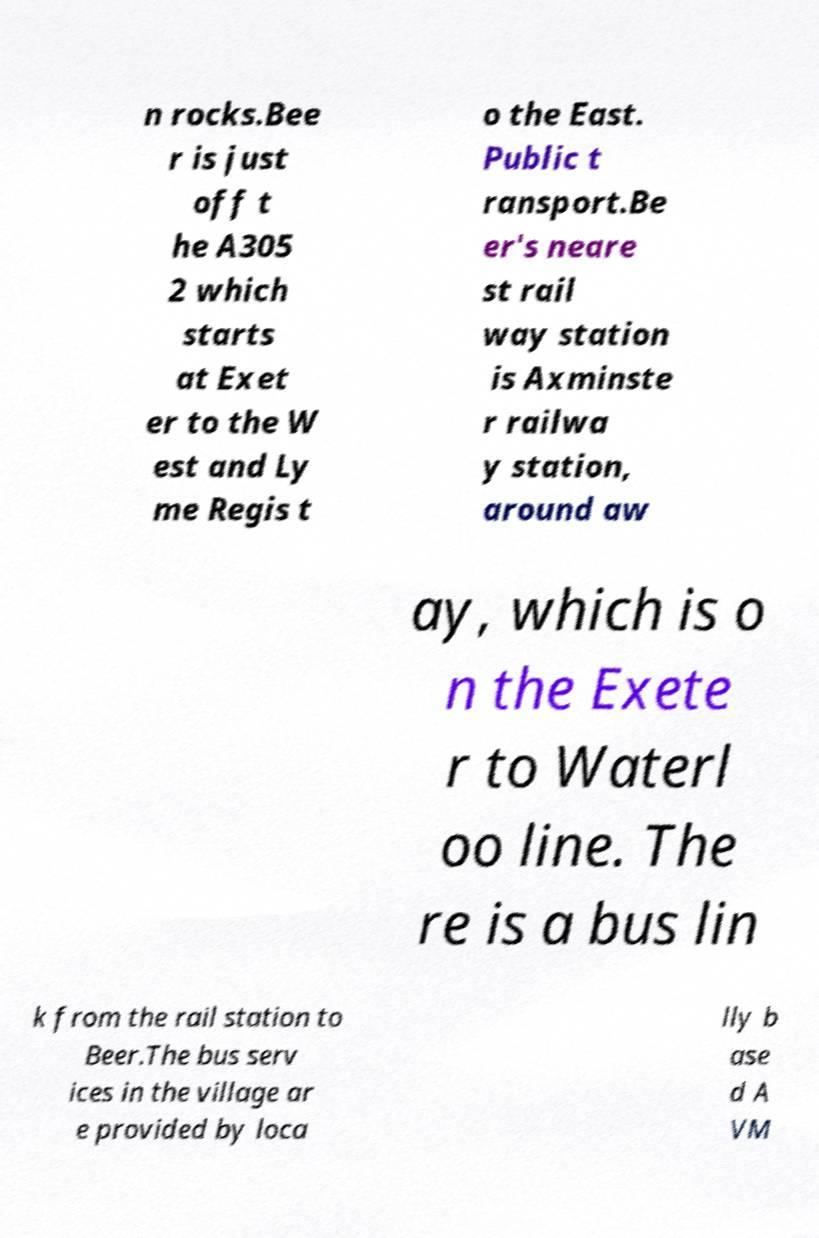I need the written content from this picture converted into text. Can you do that? n rocks.Bee r is just off t he A305 2 which starts at Exet er to the W est and Ly me Regis t o the East. Public t ransport.Be er's neare st rail way station is Axminste r railwa y station, around aw ay, which is o n the Exete r to Waterl oo line. The re is a bus lin k from the rail station to Beer.The bus serv ices in the village ar e provided by loca lly b ase d A VM 